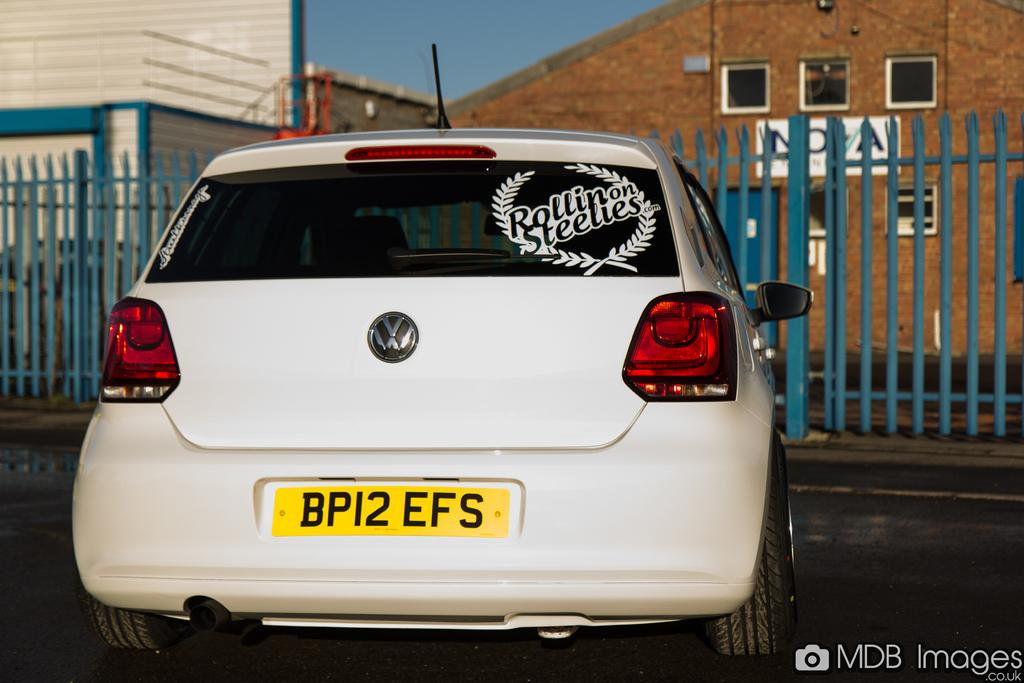Provide a one-sentence caption for the provided image. White volkswagon is parked with a rollin on steelies sign on the back. 